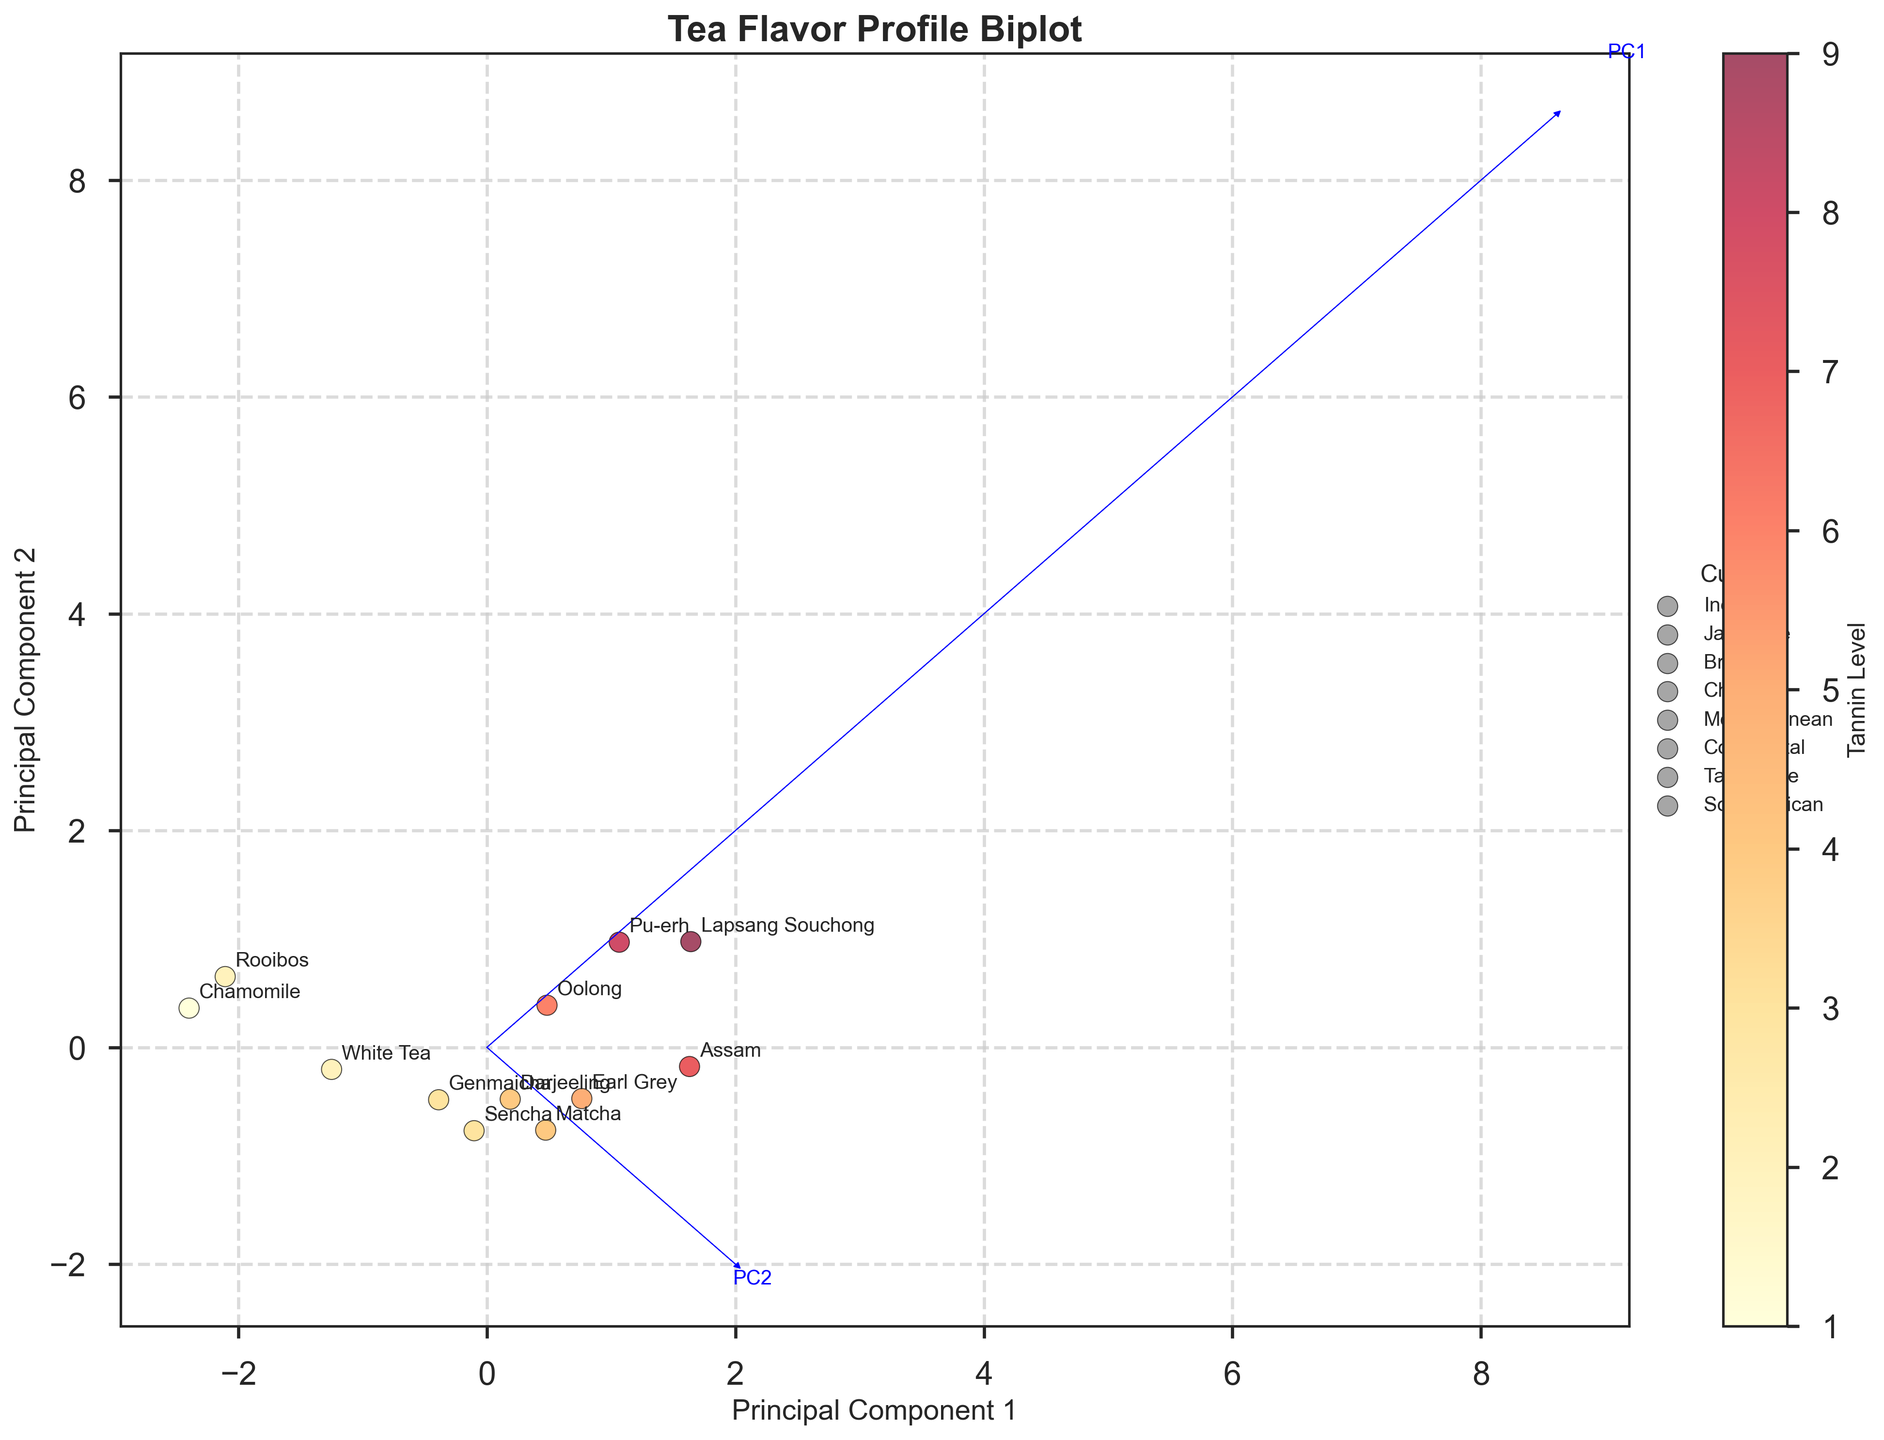Can you identify the tea with the highest tannin level? By looking at the plot, find the tea label that is positioned highest on the Principal Component that represents the Tannin Level. Then, look for the corresponding tea label on the plot.
Answer: Lapsang Souchong Which cuisine is most frequently represented in the plot? By counting the number of labels under each cuisine in the legend, we can determine that Japanese cuisine appears the most, with three different teas represented.
Answer: Japanese What is the general relationship between the tannin level and caffeine level in the teas? Observing the plot, note that teas with higher tannin levels (as indicated by darker color points) generally have higher caffeine levels, shown by the positioning in the upper or right part of the left principal component. This indicates a positive correlation.
Answer: Positive correlation How many teas have a tannin level of less than 5? By referring to the color intensity on the scatter plot, count the number of tea points that are in the lighter color range, corresponding to the tannin level < 5.
Answer: Four teas Which teas are clustered closely together? Look for groups of tea labels that are positioned near each other on the plot. From visual inspection, Sencha and Genmaicha as well as Pu-erh and Oolong are clustered closely together.
Answer: Sencha and Genmaicha, Pu-erh and Oolong Which principal component explains the most variance in the data? By looking at the arrows representing eigenvectors, and their corresponding text labels for PCs, the length of the arrow and its text label will indicate which PC explains more variance. Based on typical biplot conventions, PC1 usually explains more variance.
Answer: PC1 Are there any teas that could be outliers based on their flavor profile? Scan for points that are separated far from clusters of other points. Lapsang Souchong and Rooibos appear as outliers, positioned away from clusters.
Answer: Lapsang Souchong, Rooibos What tea pairs well with spicy curry and which cuisine is it from? Locate the label for the tea that is paired with spicy curry by following the annotations on the figure, and then identify its cuisine. The tea is Assam, and it is from Indian cuisine.
Answer: Assam, Indian 